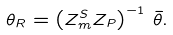Convert formula to latex. <formula><loc_0><loc_0><loc_500><loc_500>\theta _ { R } = \left ( Z _ { m } ^ { S } Z _ { P } \right ) ^ { - 1 } \, \bar { \theta } .</formula> 